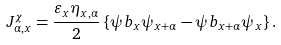<formula> <loc_0><loc_0><loc_500><loc_500>J ^ { \chi } _ { \alpha , x } = \frac { \varepsilon _ { x } \eta _ { x , \alpha } } { 2 } \left \{ \psi b _ { x } \psi _ { x + \alpha } - \psi b _ { x + \alpha } \psi _ { x } \right \} .</formula> 